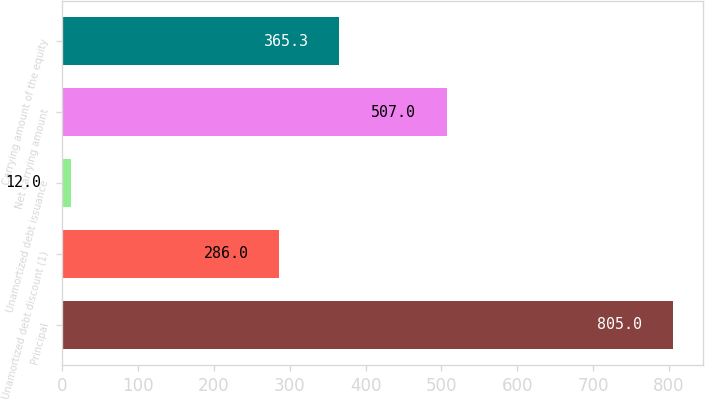<chart> <loc_0><loc_0><loc_500><loc_500><bar_chart><fcel>Principal<fcel>Unamortized debt discount (1)<fcel>Unamortized debt issuance<fcel>Net carrying amount<fcel>Carrying amount of the equity<nl><fcel>805<fcel>286<fcel>12<fcel>507<fcel>365.3<nl></chart> 